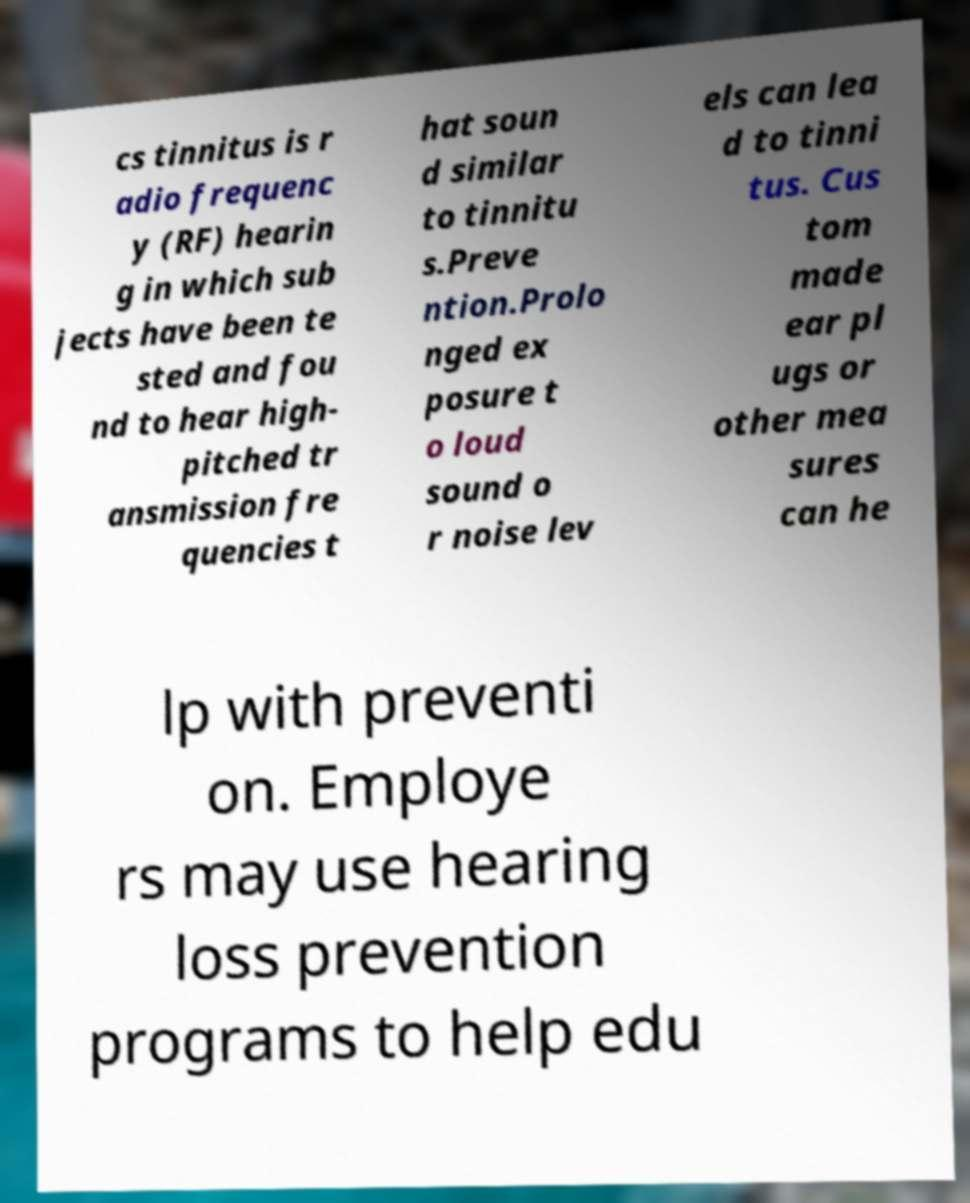There's text embedded in this image that I need extracted. Can you transcribe it verbatim? cs tinnitus is r adio frequenc y (RF) hearin g in which sub jects have been te sted and fou nd to hear high- pitched tr ansmission fre quencies t hat soun d similar to tinnitu s.Preve ntion.Prolo nged ex posure t o loud sound o r noise lev els can lea d to tinni tus. Cus tom made ear pl ugs or other mea sures can he lp with preventi on. Employe rs may use hearing loss prevention programs to help edu 